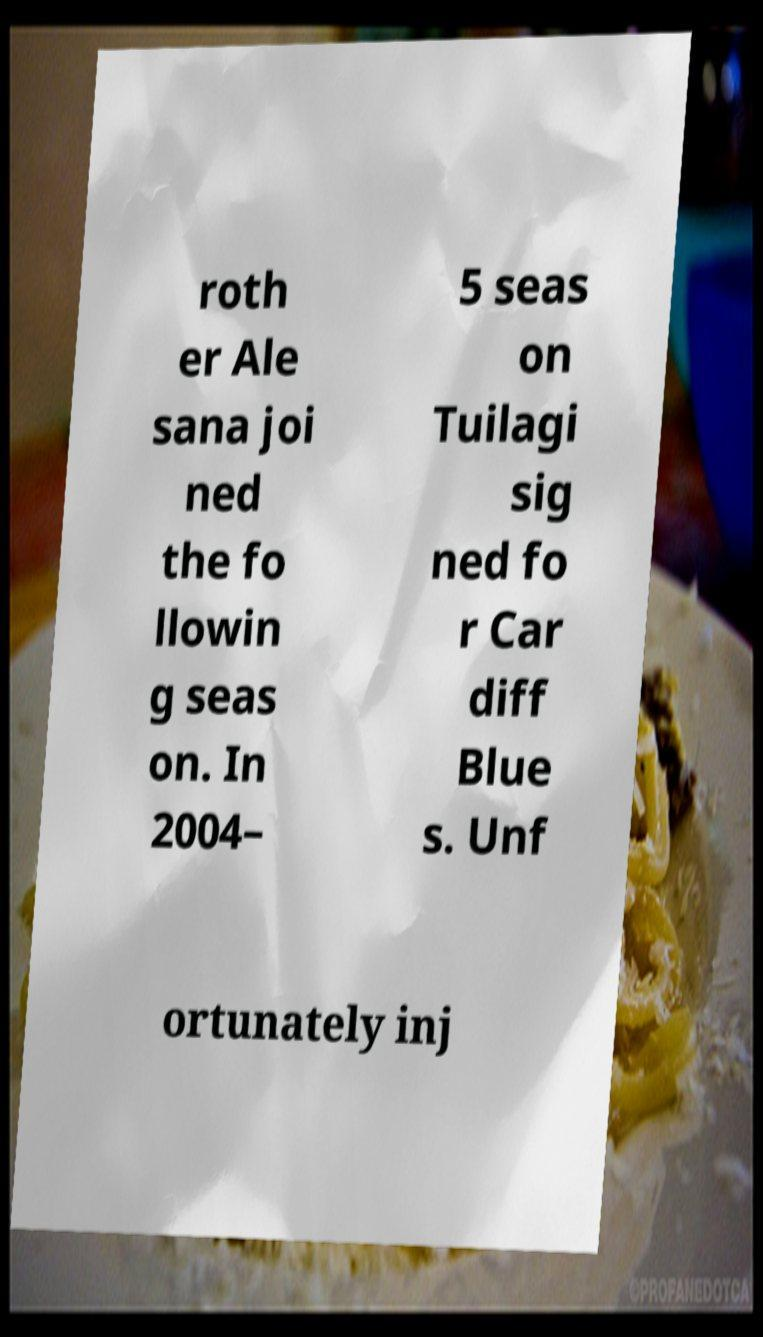For documentation purposes, I need the text within this image transcribed. Could you provide that? roth er Ale sana joi ned the fo llowin g seas on. In 2004– 5 seas on Tuilagi sig ned fo r Car diff Blue s. Unf ortunately inj 